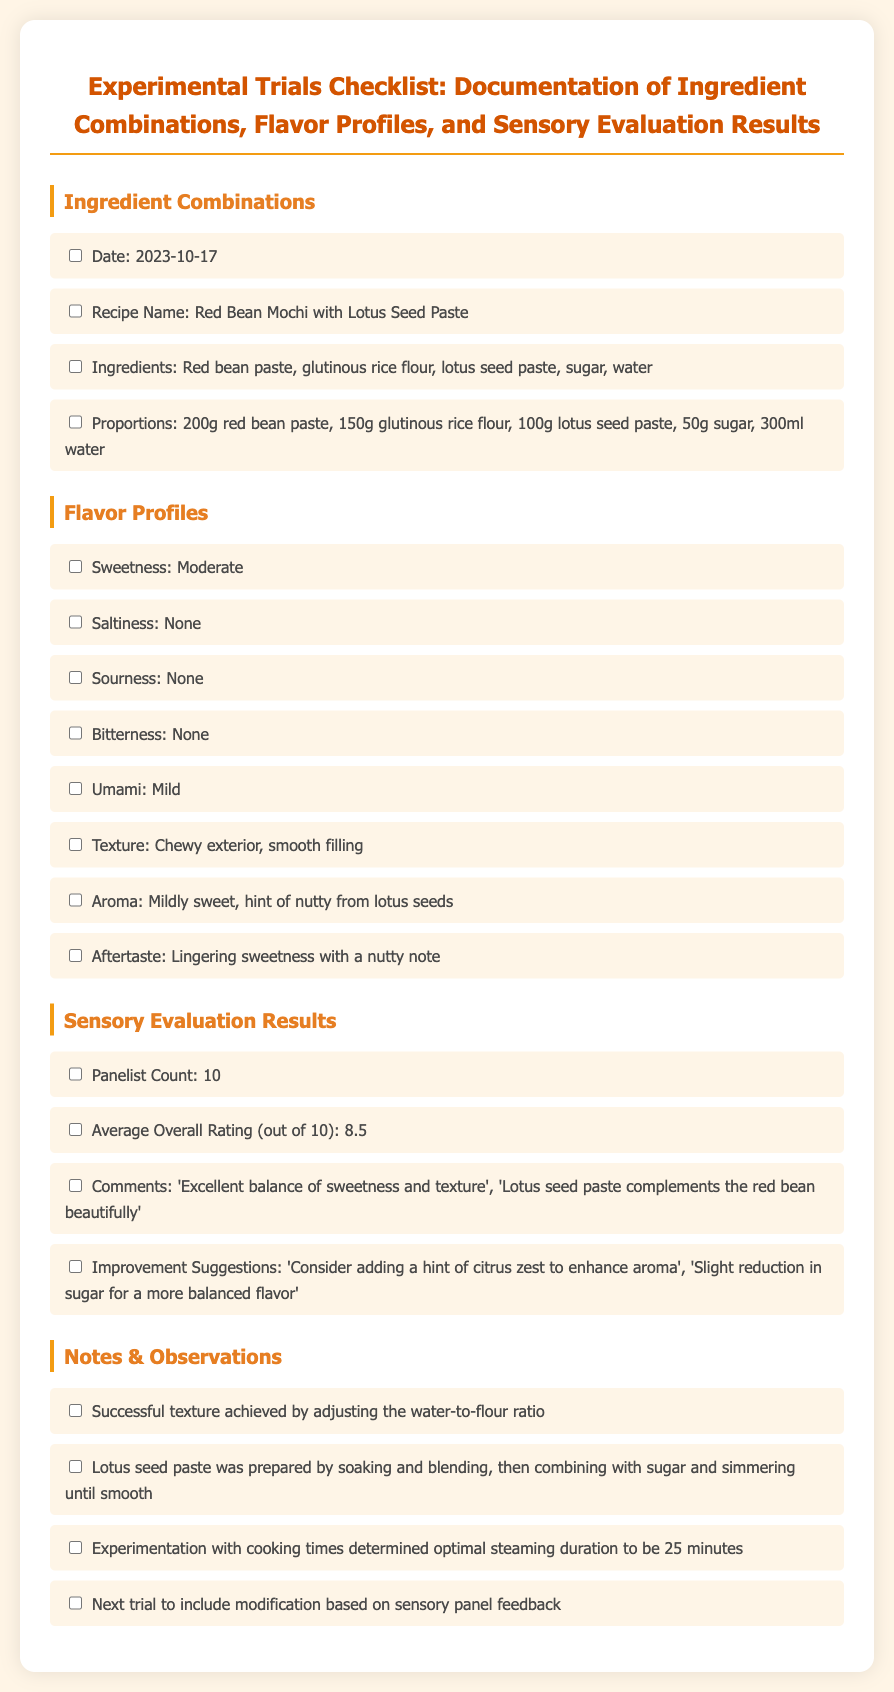what is the date of the experimental trial? The date of the experimental trial is listed at the beginning of the ingredient combinations section.
Answer: 2023-10-17 what is the recipe name? The recipe name is provided under the ingredient combinations section of the document.
Answer: Red Bean Mochi with Lotus Seed Paste how many panelists were involved in the sensory evaluation? The number of panelists is stated in the sensory evaluation results section.
Answer: 10 what was the average overall rating? The average overall rating is mentioned in the sensory evaluation results.
Answer: 8.5 what is the texture of the dessert? The texture description is found in the flavor profiles section, outlining the specific characteristics.
Answer: Chewy exterior, smooth filling which flavor profile describes aftertaste? The aftertaste description is provided in the flavor profiles section, indicating a specific characteristic.
Answer: Lingering sweetness with a nutty note what improvement suggestion involves aroma? The improvement suggestion that relates to aroma can be found in the sensory evaluation results section.
Answer: Consider adding a hint of citrus zest to enhance aroma what successful texture achievement method is noted? The method for achieving successful texture is stated in the notes & observations section of the document.
Answer: Adjusting the water-to-flour ratio what ingredient was prepared by soaking and blending? The ingredient that was specifically prepared in this manner is mentioned in the notes & observations section.
Answer: Lotus seed paste 